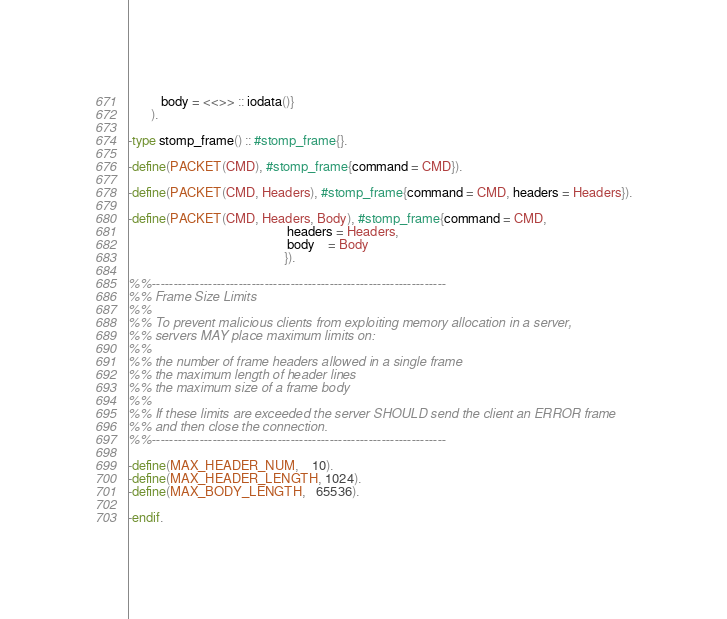Convert code to text. <code><loc_0><loc_0><loc_500><loc_500><_Erlang_>          body = <<>> :: iodata()}
       ).

-type stomp_frame() :: #stomp_frame{}.

-define(PACKET(CMD), #stomp_frame{command = CMD}).

-define(PACKET(CMD, Headers), #stomp_frame{command = CMD, headers = Headers}).

-define(PACKET(CMD, Headers, Body), #stomp_frame{command = CMD,
                                                 headers = Headers,
                                                 body    = Body
                                                }).

%%--------------------------------------------------------------------
%% Frame Size Limits
%%
%% To prevent malicious clients from exploiting memory allocation in a server,
%% servers MAY place maximum limits on:
%%
%% the number of frame headers allowed in a single frame
%% the maximum length of header lines
%% the maximum size of a frame body
%%
%% If these limits are exceeded the server SHOULD send the client an ERROR frame
%% and then close the connection.
%%--------------------------------------------------------------------

-define(MAX_HEADER_NUM,    10).
-define(MAX_HEADER_LENGTH, 1024).
-define(MAX_BODY_LENGTH,   65536).

-endif.
</code> 